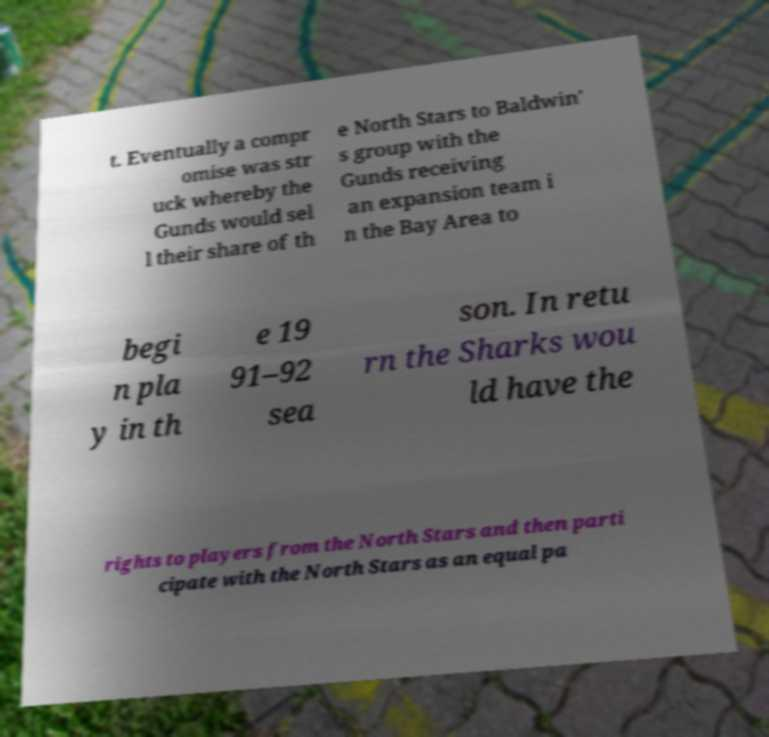I need the written content from this picture converted into text. Can you do that? t. Eventually a compr omise was str uck whereby the Gunds would sel l their share of th e North Stars to Baldwin' s group with the Gunds receiving an expansion team i n the Bay Area to begi n pla y in th e 19 91–92 sea son. In retu rn the Sharks wou ld have the rights to players from the North Stars and then parti cipate with the North Stars as an equal pa 